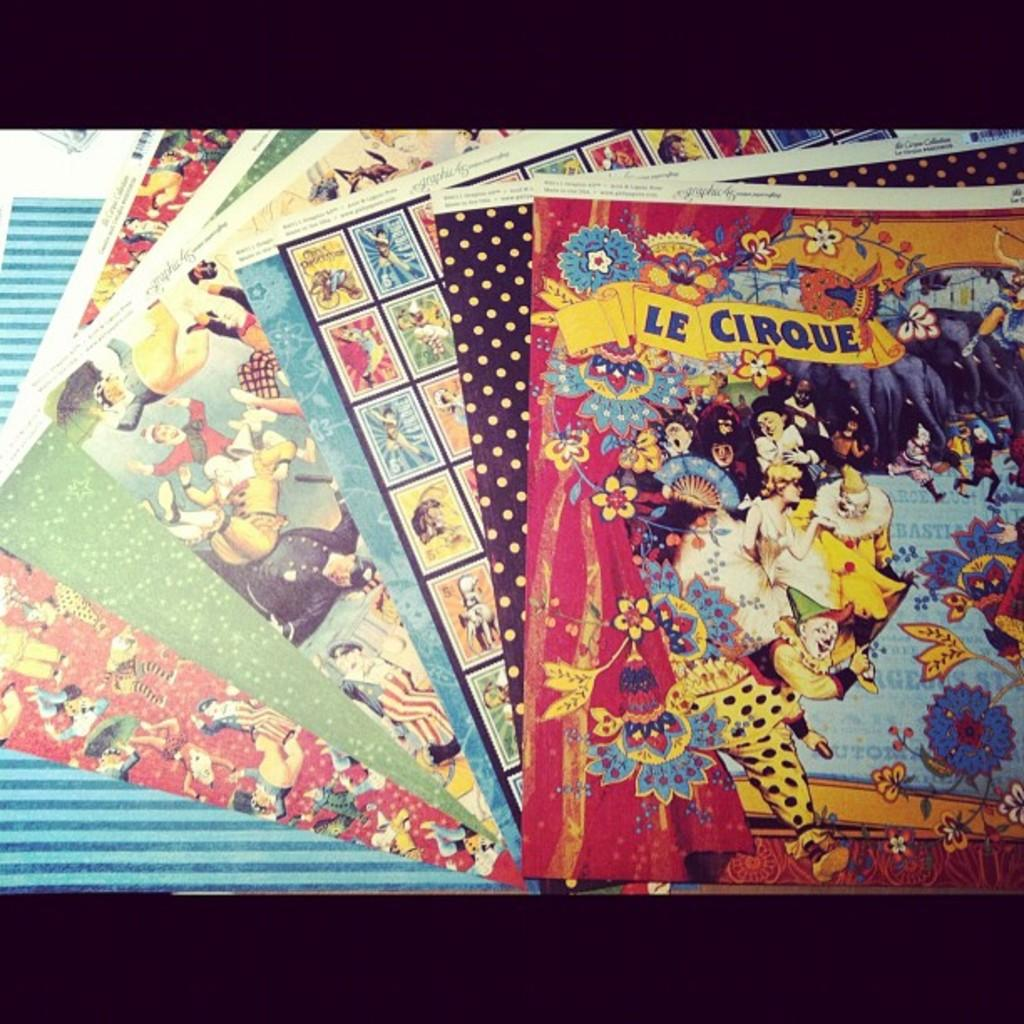Provide a one-sentence caption for the provided image. A collection of booklets sit on a table with the top book titled LE CIRQUE. 